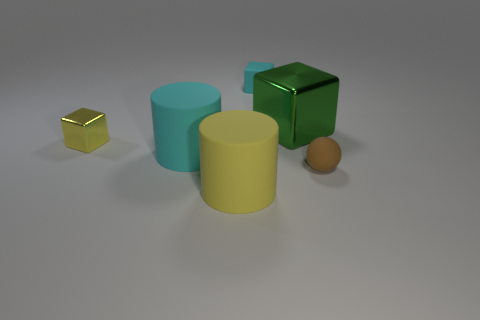Subtract all metal cubes. How many cubes are left? 1 Add 3 large matte cylinders. How many objects exist? 9 Subtract 1 cubes. How many cubes are left? 2 Subtract all big purple cylinders. Subtract all green objects. How many objects are left? 5 Add 4 large cyan cylinders. How many large cyan cylinders are left? 5 Add 6 large green objects. How many large green objects exist? 7 Subtract 1 yellow cubes. How many objects are left? 5 Subtract all cylinders. How many objects are left? 4 